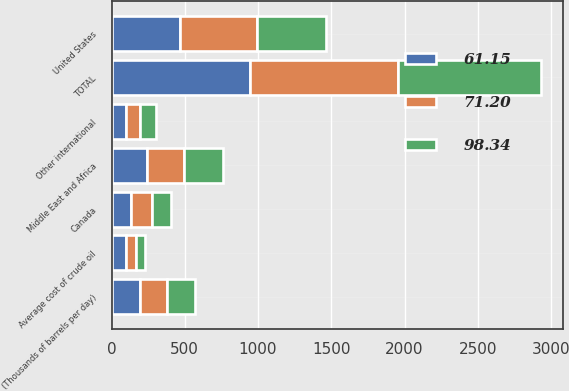<chart> <loc_0><loc_0><loc_500><loc_500><stacked_bar_chart><ecel><fcel>(Thousands of barrels per day)<fcel>United States<fcel>Canada<fcel>Middle East and Africa<fcel>Other international<fcel>TOTAL<fcel>Average cost of crude oil<nl><fcel>61.15<fcel>191<fcel>466<fcel>135<fcel>244<fcel>99<fcel>944<fcel>98.34<nl><fcel>71.2<fcel>191<fcel>527<fcel>138<fcel>253<fcel>92<fcel>1010<fcel>71.2<nl><fcel>98.34<fcel>191<fcel>470<fcel>130<fcel>266<fcel>114<fcel>980<fcel>61.15<nl></chart> 